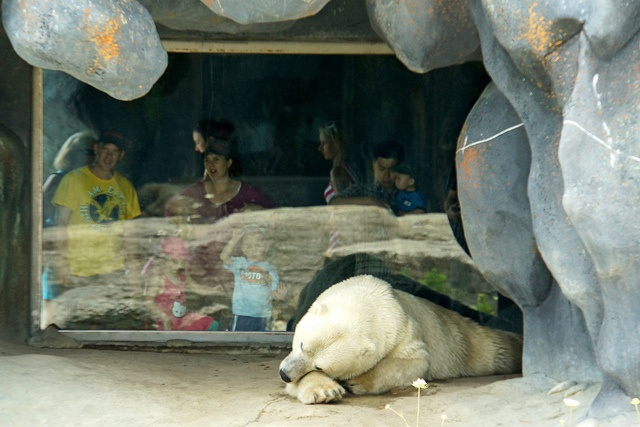Describe the objects in this image and their specific colors. I can see bear in black, beige, and gray tones, people in black, olive, and gray tones, people in black, darkgray, gray, and blue tones, people in black, darkgreen, and gray tones, and people in black, darkgreen, and gray tones in this image. 